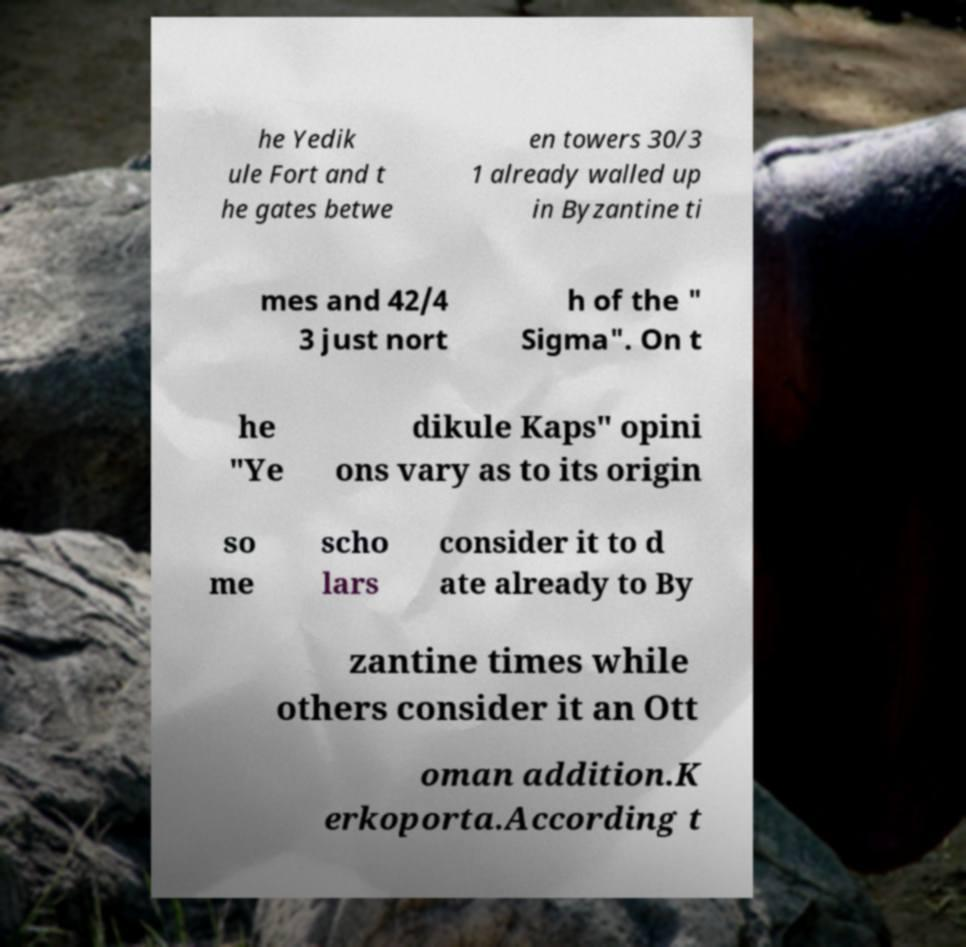Please identify and transcribe the text found in this image. he Yedik ule Fort and t he gates betwe en towers 30/3 1 already walled up in Byzantine ti mes and 42/4 3 just nort h of the " Sigma". On t he "Ye dikule Kaps" opini ons vary as to its origin so me scho lars consider it to d ate already to By zantine times while others consider it an Ott oman addition.K erkoporta.According t 